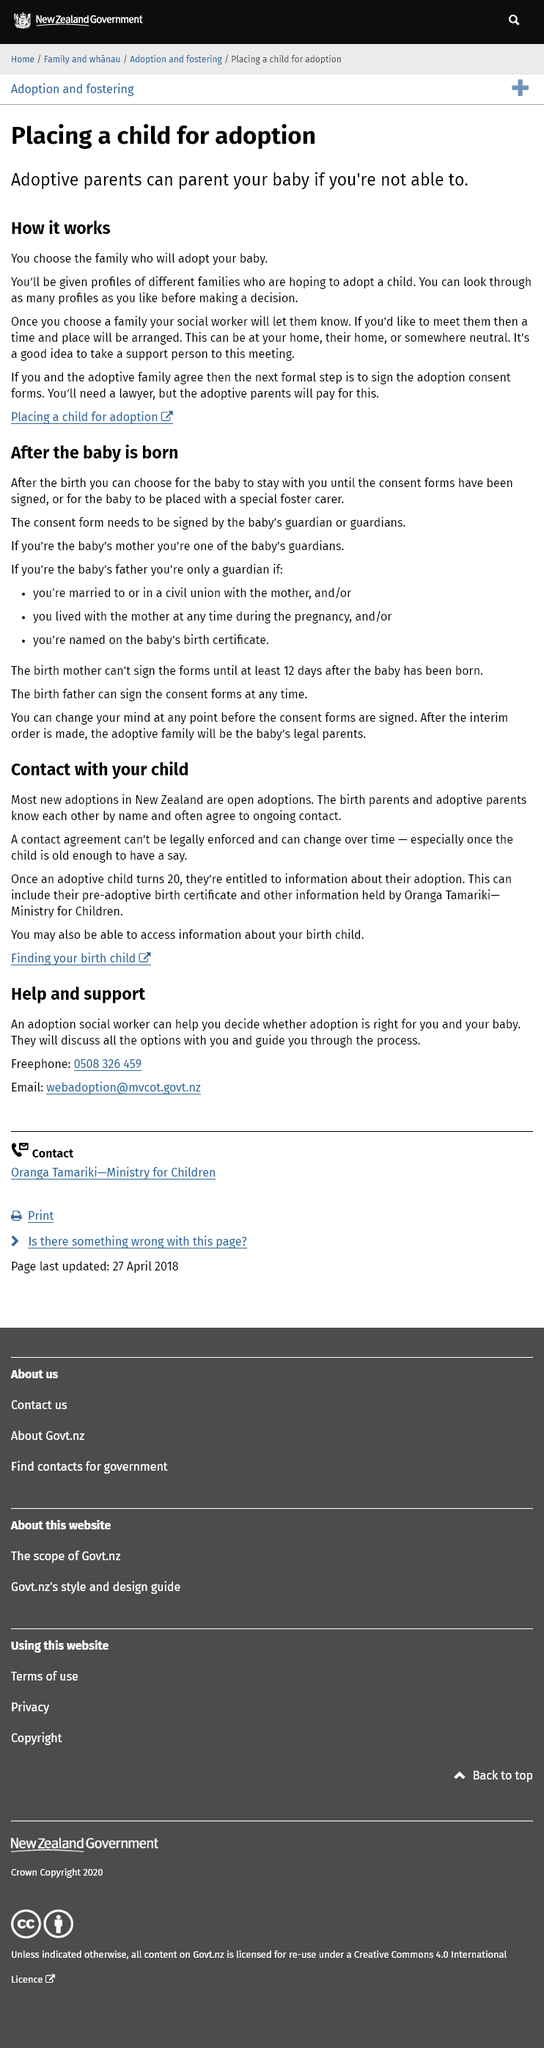Draw attention to some important aspects in this diagram. The adoptive parents are responsible for paying the lawyer fees involved in signing the adoption consent forms. It is possible to meet the family who will be adopting your baby at your residence, their residence, or at a neutral location. Yes, you can choose the parents who will be adopting your baby. 